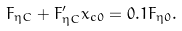Convert formula to latex. <formula><loc_0><loc_0><loc_500><loc_500>F _ { \eta C } + F ^ { \prime } _ { \eta C } x _ { c 0 } = 0 . 1 F _ { \eta 0 } .</formula> 